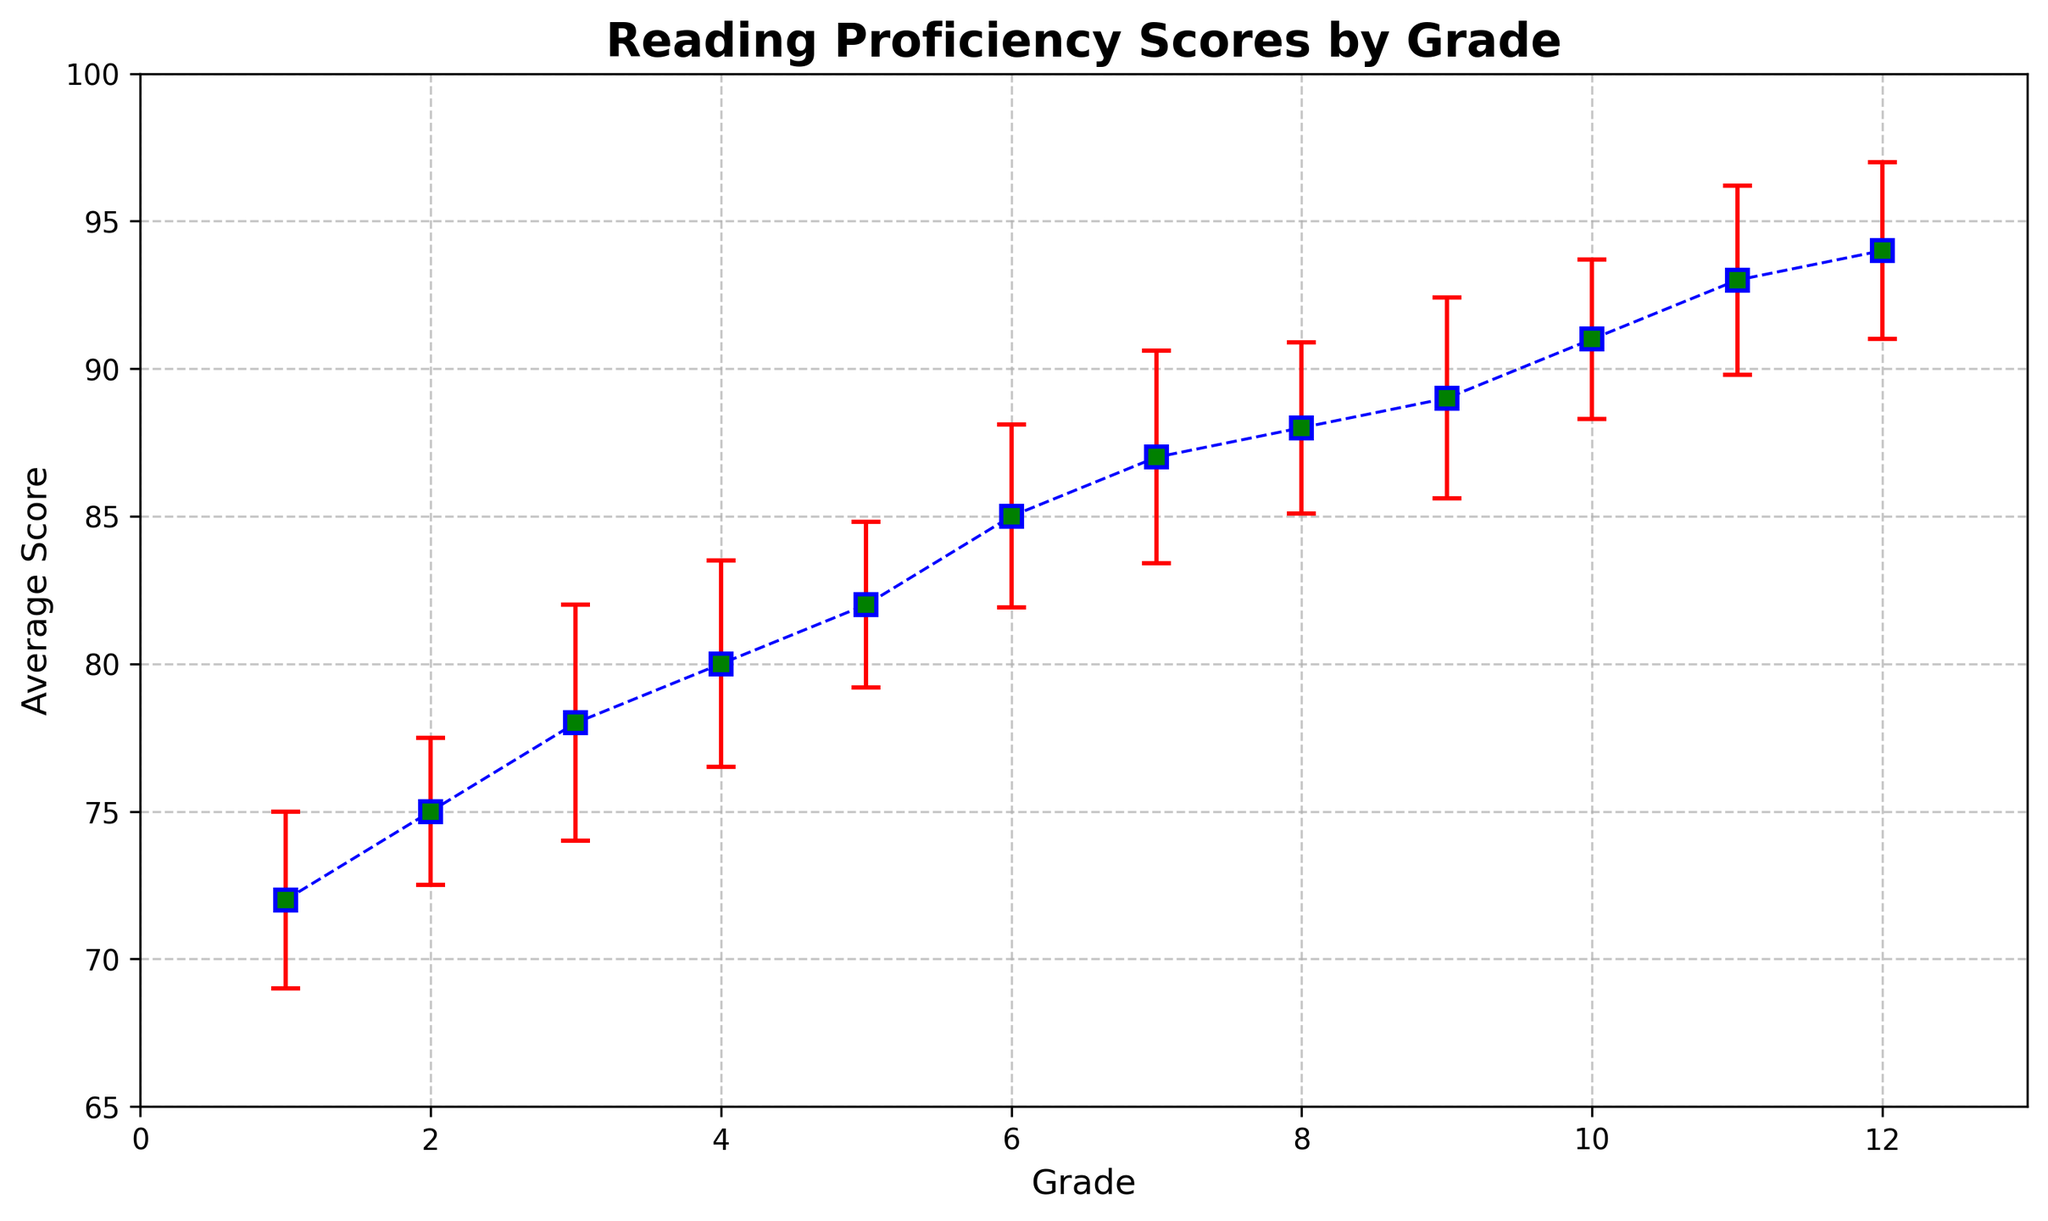How does the average score change from Grade 1 to Grade 12? To determine the change, subtract the average score of Grade 1 from that of Grade 12: 94 (Grade 12) - 72 (Grade 1) = 22.
Answer: 22 Which grade has the highest average reading proficiency score? Look at the data points and find the grade with the highest value, which is 94, associated with Grade 12.
Answer: Grade 12 Between which consecutive grades is the increase in average score the largest? Calculate the difference in average scores between all consecutive grades and identify the largest: The largest increase is 3 (from Grade 2 to Grade 3, 75 to 78). Other increases are smaller.
Answer: From Grade 2 to Grade 3 What is the average reading proficiency score for Grades 10 through 12? Calculate the average of the scores for Grades 10, 11, and 12: (91 + 93 + 94) / 3 = 92.67.
Answer: 92.67 For which grade is the measurement error the highest? Examine the measurement error values and find the highest, which is 4 for Grade 3.
Answer: Grade 3 Is the trend of average scores generally increasing, decreasing, or staying the same as grade level increases? Observe the plotted data points and the overall trend line, which shows consistently increasing average scores.
Answer: Increasing Which two grades have the closest average scores? Identify grades with minimal difference: Grades 8 and 9 have an average score of 88 and 89 respectively, with a difference of 1.
Answer: Grades 8 and 9 What is the total sum of the average reading proficiency scores for all grades? Add up all the average scores: 72 + 75 + 78 + 80 + 82 + 85 + 87 + 88 + 89 + 91 + 93 + 94 = 1014.
Answer: 1014 What is the difference in average scores between Grade 6 and Grade 11? Subtract the average score of Grade 6 from that of Grade 11: 93 (Grade 11) - 85 (Grade 6) = 8.
Answer: 8 